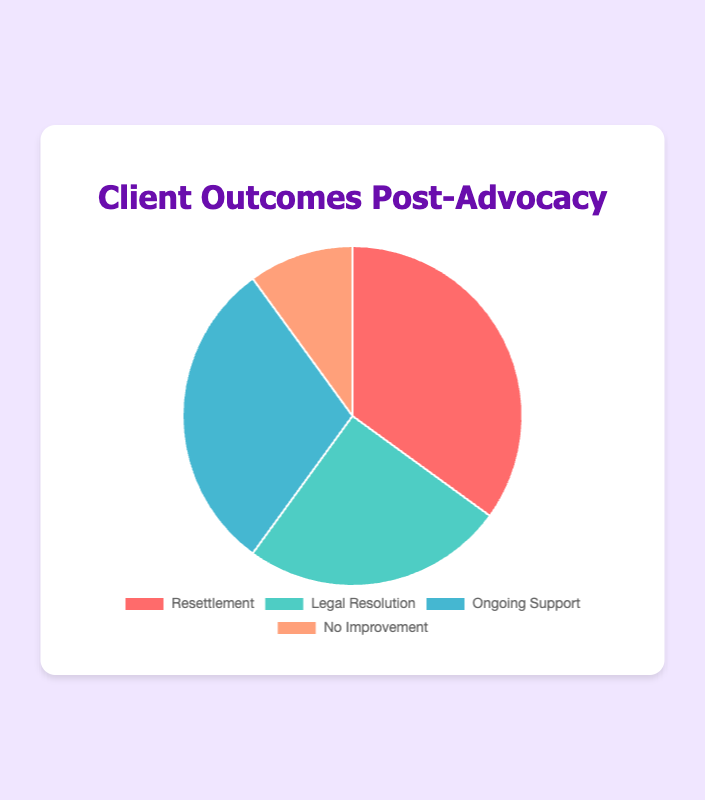Which outcome has the highest percentage? By looking at the pie chart, you can see which slice is the largest. The largest slice represents "Resettlement".
Answer: Resettlement What's the combined percentage of clients who received ongoing support and those who had legal resolution? Sum the percentages of "Ongoing Support" (30%) and "Legal Resolution" (25%). 30% + 25% = 55%.
Answer: 55% Is the percentage of clients experiencing no improvement greater than or less than 15%? By inspecting the chart, you can see that the "No Improvement" slice corresponds to 10%, which is less than 15%.
Answer: Less than Which outcome category is represented by the red slice? The colors in the pie chart can be associated with each category. Based on the provided data and chart colors, the red slice corresponds to "Resettlement".
Answer: Resettlement By how much does the percentage of resettlement exceed that of legal resolution? Subtract the percentage of "Legal Resolution" (25%) from that of "Resettlement" (35%). 35% - 25% = 10%.
Answer: 10% What fraction of clients experienced ongoing support? The percentage for "Ongoing Support" is 30%. Convert this to a fraction by dividing by 100, resulting in 30/100 which simplifies to 3/10.
Answer: 3/10 Rank the outcomes from highest to lowest percentage. Compare the percentages of all categories: "Resettlement" (35%), "Ongoing Support" (30%), "Legal Resolution" (25%), "No Improvement" (10%). The ranking from highest to lowest is "Resettlement", "Ongoing Support", "Legal Resolution", "No Improvement".
Answer: Resettlement, Ongoing Support, Legal Resolution, No Improvement What is the difference between the combined percentage of "Resettlement" and "Legal Resolution" compared to the combined percentage of "Ongoing Support" and "No Improvement"? Sum the percentages of "Resettlement" (35%) and "Legal Resolution" (25%) to get 60%. Sum the percentages of "Ongoing Support" (30%) and "No Improvement" (10%) to get 40%. Subtract the two totals: 60% - 40% = 20%.
Answer: 20% 